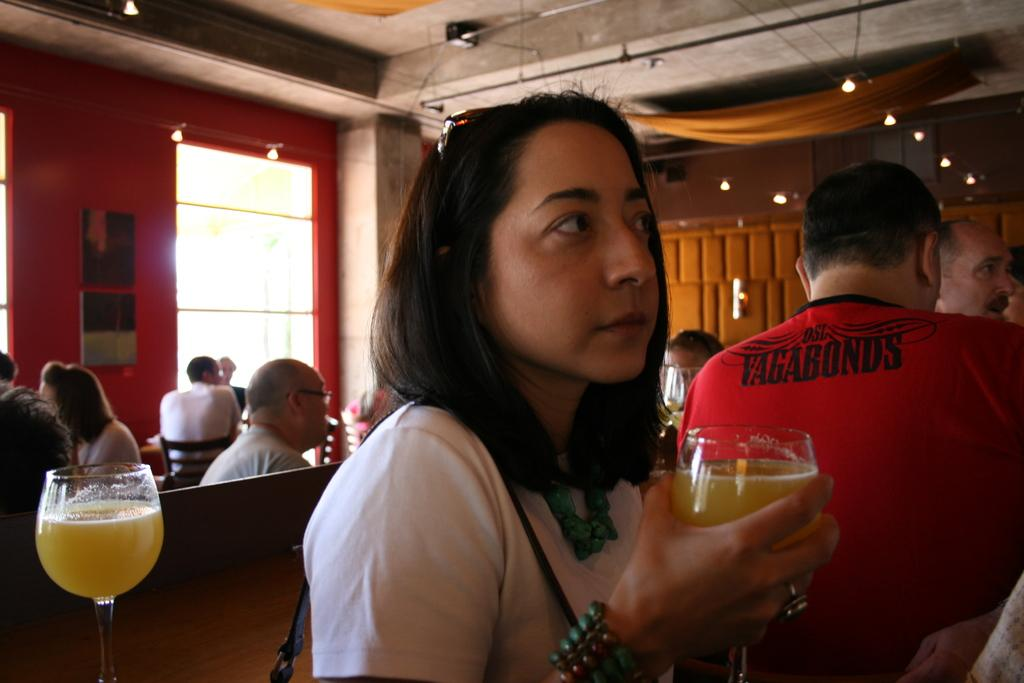How many people are in the image? There is a group of people in the image. What are some of the people doing in the image? Some of the people are sitting. Can you describe what one person is holding in the image? One person is holding a glass. What can be seen in the background of the image? There are lights visible in the image. Is there any source of natural light in the image? Yes, there is a window in the image. What type of plantation is visible through the window in the image? There is no plantation visible through the window in the image. 